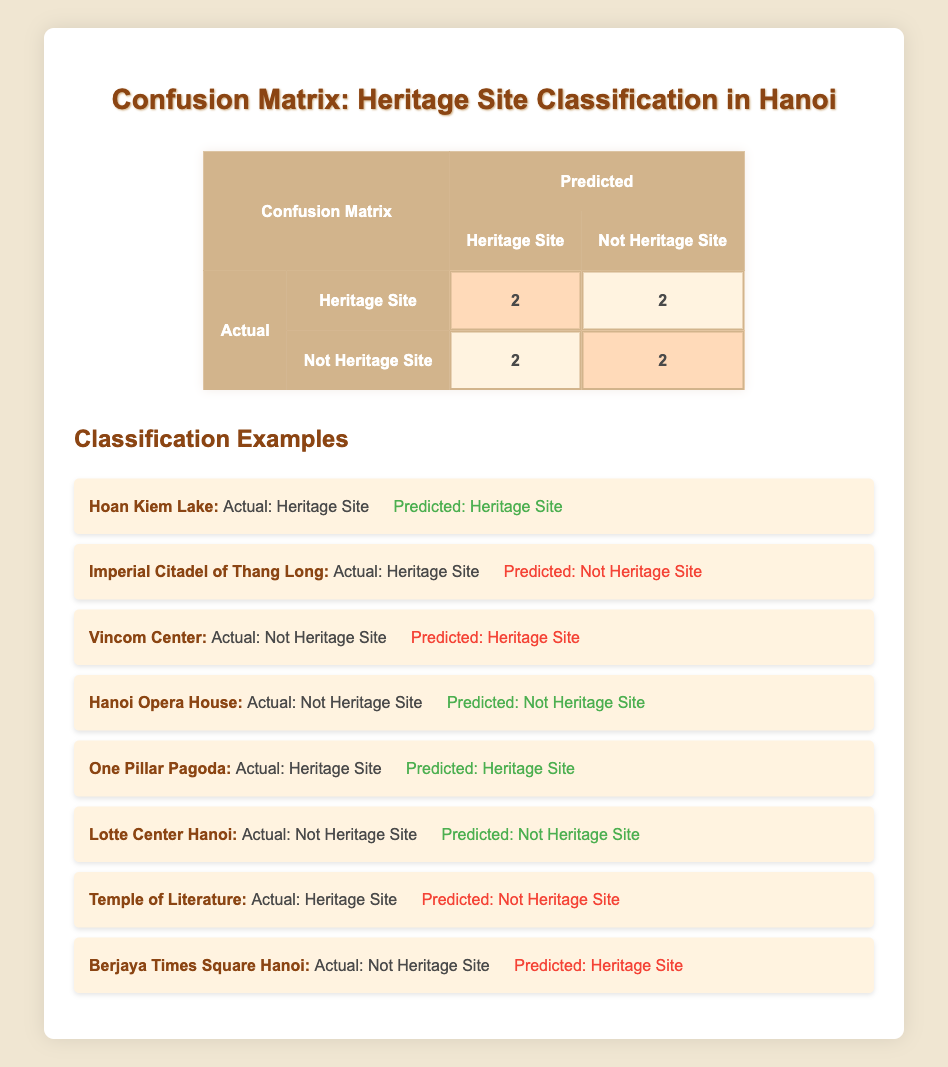What is the total number of Heritage Sites classified correctly? Referring to the table, there are 2 instances where Heritage Sites were predicted correctly: "Hoan Kiem Lake" and "One Pillar Pagoda". Therefore, the total number is 2.
Answer: 2 How many Not Heritage Sites were misclassified as Heritage Sites? The table shows 2 instances where Not Heritage Sites were incorrectly predicted as Heritage Sites: "Vincom Center" and "Berjaya Times Square Hanoi". Thus, the total count is 2.
Answer: 2 Did the Hanoi Opera House receive the correct classification? According to the table, the actual classification of Hanoi Opera House is "Not Heritage Site", and it was also predicted as "Not Heritage Site", confirming that it received the correct classification.
Answer: Yes What is the ratio of correctly predicted Heritage Sites to incorrectly predicted Heritage Sites? There are 2 correctly predicted Heritage Sites and 3 incorrectly predicted Heritage Sites (with 2 being incorrectly classified Not Heritage Sites as Heritage Sites). The ratio of correct to incorrect is 2:3.
Answer: 2:3 Is the prediction accuracy for Not Heritage Sites higher than for Heritage Sites? For Not Heritage Sites, there are 2 correctly predicted and 2 incorrectly predicted, leading to an accuracy of 50%. For Heritage Sites, there are 2 correctly predicted and 2 incorrectly predicted, also leading to an accuracy of 50%. Therefore, the accuracy is the same, and Not Heritage Sites do not have a higher accuracy.
Answer: No What are the total instances where Heritage Sites were predicted incorrectly? The table indicates that there are 2 instances of incorrectly predicted Heritage Sites ("Imperial Citadel of Thang Long" and "Temple of Literature"). Summing these gives the total of 2.
Answer: 2 Which site was incorrectly classified as Not a Heritage Site while it actually is? From the examples, "Imperial Citadel of Thang Long" was declared a Heritage Site but was predicted as Not a Heritage Site.
Answer: Imperial Citadel of Thang Long What percentage of the instances were correctly classified overall? There are 4 correct classifications (2 Heritage Sites and 2 Not Heritage Sites) out of a total of 8 instances. The percentage of correct classifications is (4/8) * 100 = 50%.
Answer: 50% 